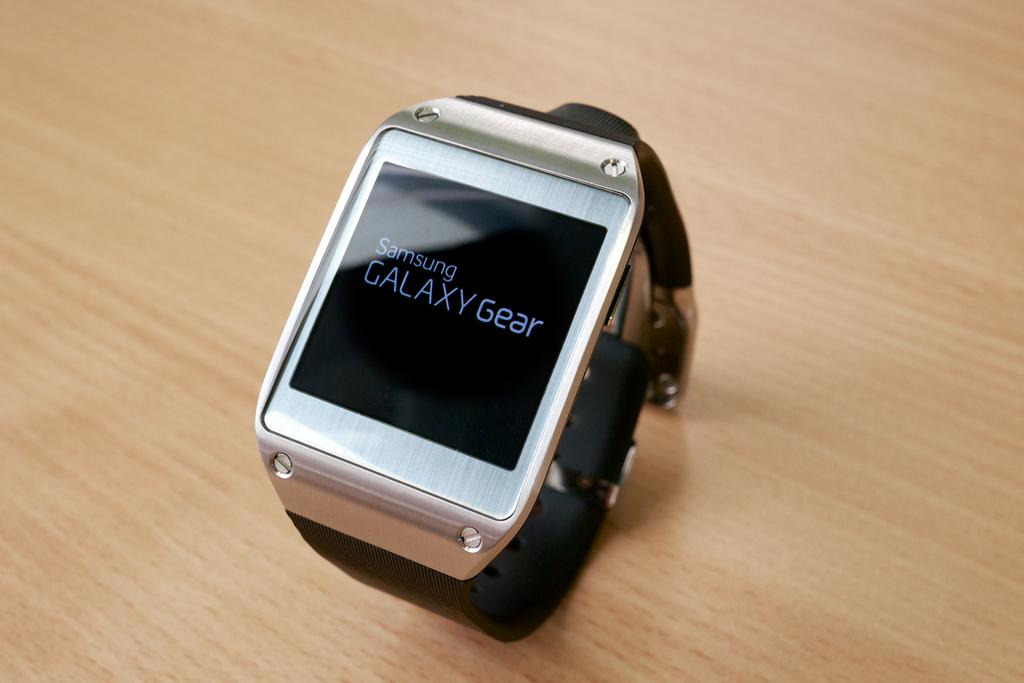<image>
Offer a succinct explanation of the picture presented. A Samsung Galaxy Gear watch is displayed on a wooden surface. 